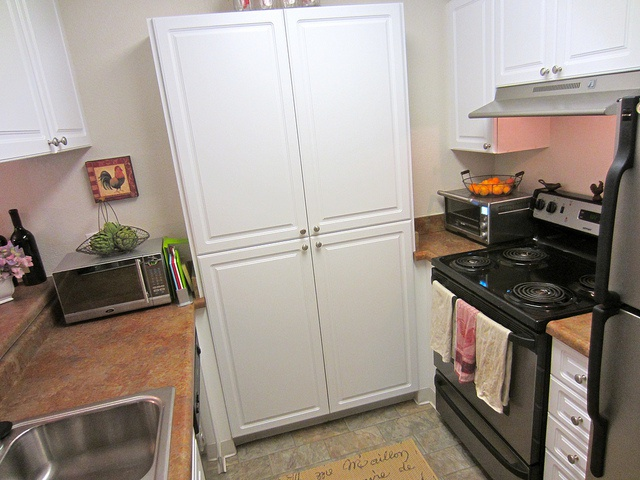Describe the objects in this image and their specific colors. I can see refrigerator in lightgray, gray, and black tones, oven in lightgray, black, and gray tones, sink in lightgray, gray, and black tones, oven in lightgray, black, and gray tones, and microwave in lightgray, black, and gray tones in this image. 